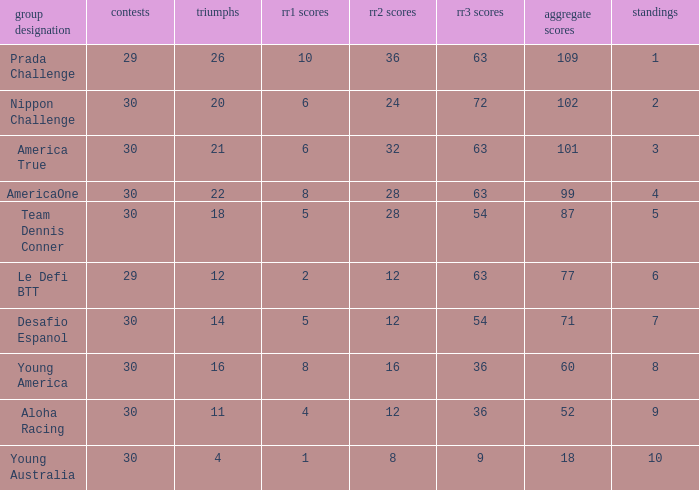Name the most rr1 pts for 7 ranking 5.0. 